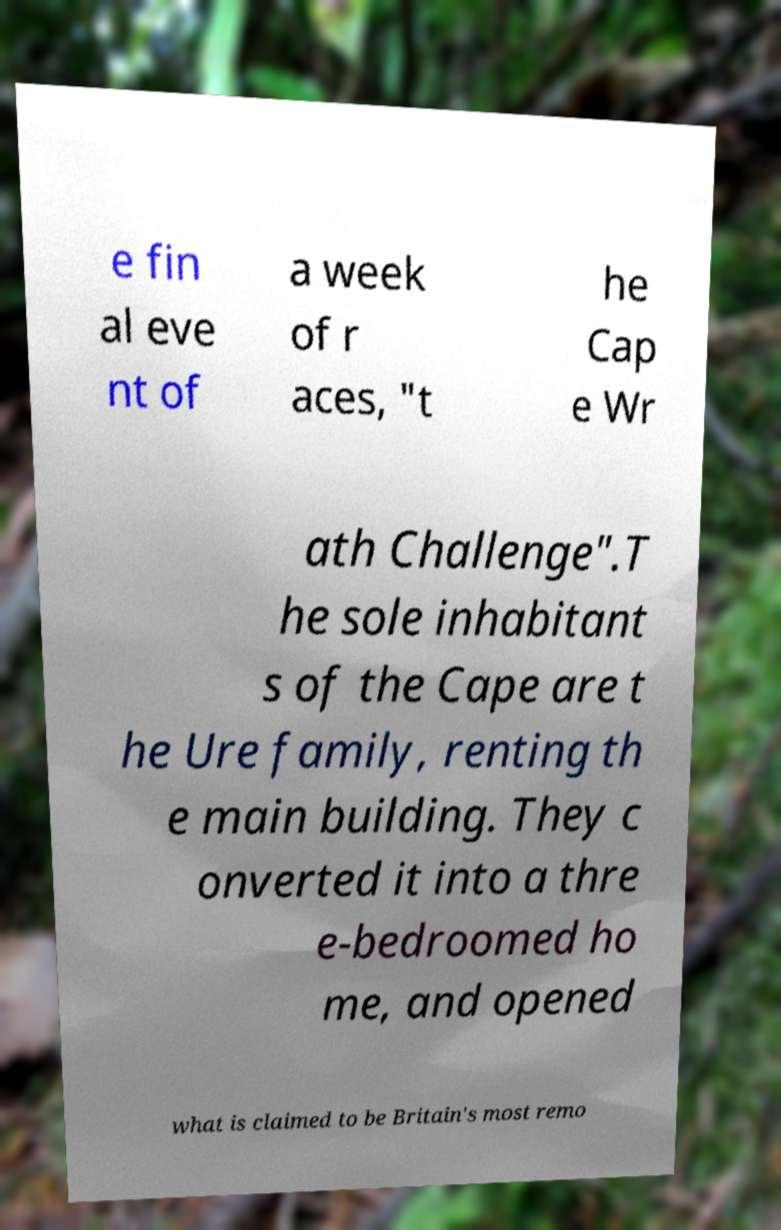I need the written content from this picture converted into text. Can you do that? e fin al eve nt of a week of r aces, "t he Cap e Wr ath Challenge".T he sole inhabitant s of the Cape are t he Ure family, renting th e main building. They c onverted it into a thre e-bedroomed ho me, and opened what is claimed to be Britain's most remo 